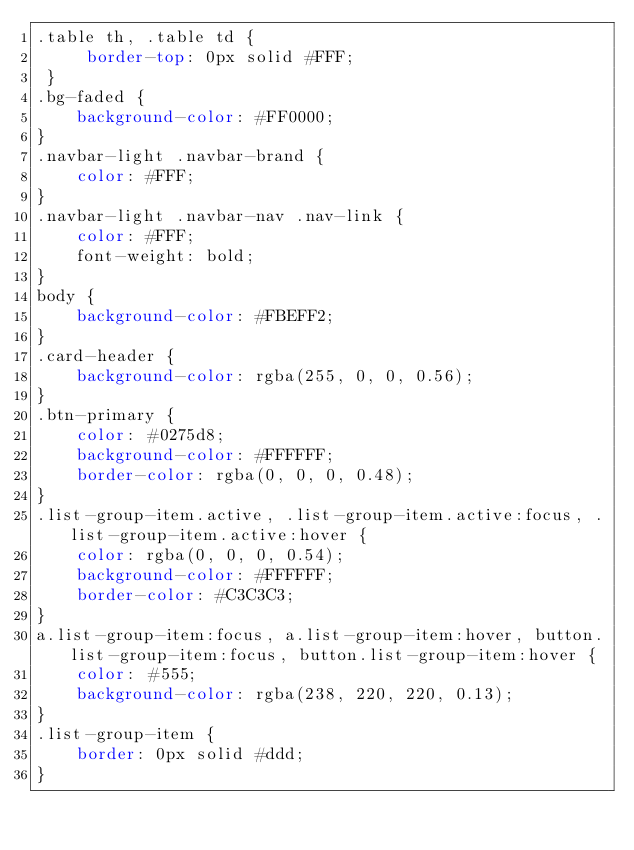<code> <loc_0><loc_0><loc_500><loc_500><_CSS_>.table th, .table td {
     border-top: 0px solid #FFF;
 }
.bg-faded {
    background-color: #FF0000;
}
.navbar-light .navbar-brand {
    color: #FFF;
}
.navbar-light .navbar-nav .nav-link {
    color: #FFF;
    font-weight: bold;
}
body {
    background-color: #FBEFF2;
}
.card-header {
    background-color: rgba(255, 0, 0, 0.56);
}
.btn-primary {
    color: #0275d8;
    background-color: #FFFFFF;
    border-color: rgba(0, 0, 0, 0.48);
}
.list-group-item.active, .list-group-item.active:focus, .list-group-item.active:hover {
    color: rgba(0, 0, 0, 0.54);
    background-color: #FFFFFF;
    border-color: #C3C3C3;
}
a.list-group-item:focus, a.list-group-item:hover, button.list-group-item:focus, button.list-group-item:hover {
    color: #555;
    background-color: rgba(238, 220, 220, 0.13);
}
.list-group-item {
    border: 0px solid #ddd;
}</code> 